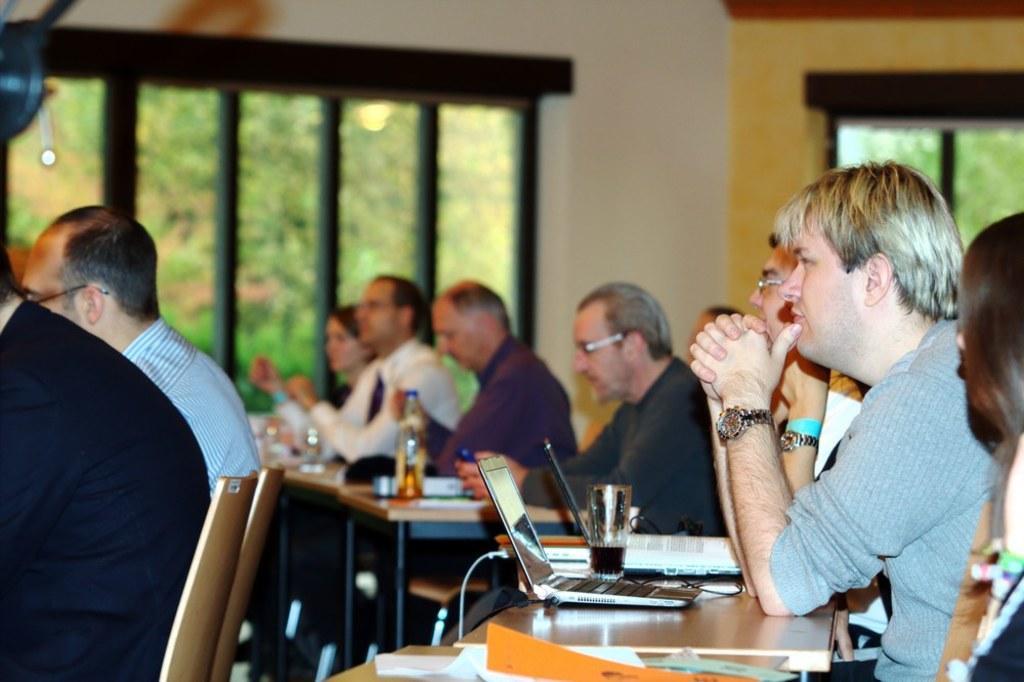Please provide a concise description of this image. In the image we can see there are people who are sitting on chairs. 